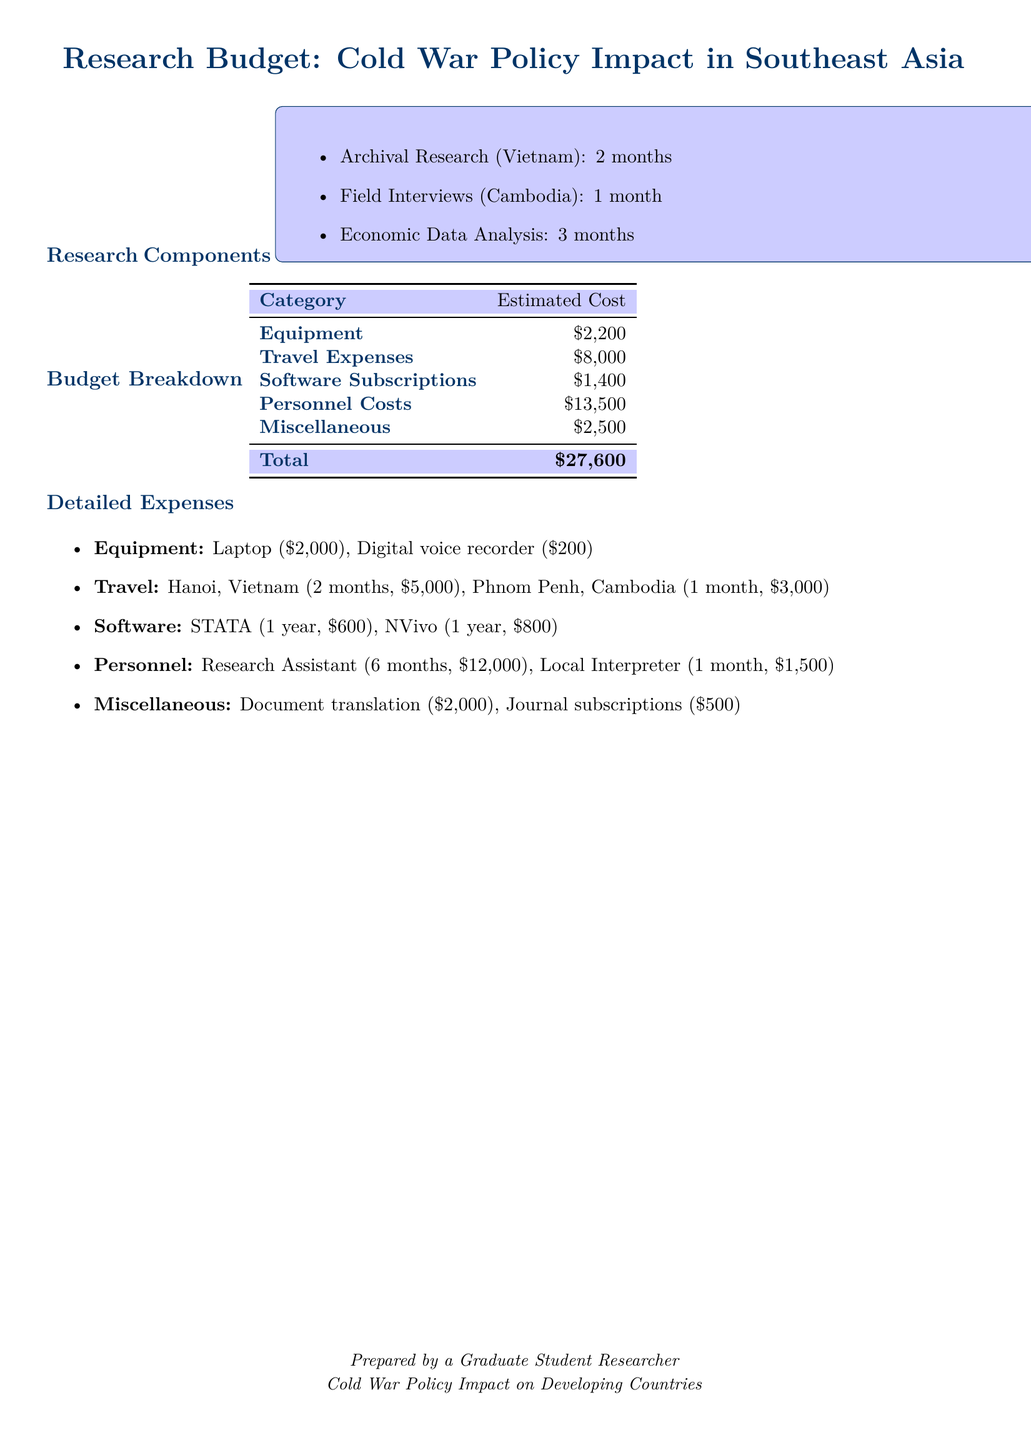What is the total estimated cost of the research? The total estimated cost is summarized in the budget breakdown section, which is $27,600.
Answer: $27,600 How many months will the archival research in Vietnam take? The duration of the archival research in Vietnam is specified as 2 months.
Answer: 2 months What is the cost of travel to Phnom Penh, Cambodia? The travel expense for Phnom Penh, Cambodia is listed as $3,000.
Answer: $3,000 Who will be hired as a research assistant? The personnel expenses indicate hiring a Research Assistant for 6 months.
Answer: Research Assistant What is the cost allocated for software subscriptions? The budget breakdown lists software subscriptions costing $1,400.
Answer: $1,400 How much is being spent on document translation? The detailed expenses include $2,000 for document translation.
Answer: $2,000 What type of software will be used for analysis? The types of software mentioned include STATA and NVivo.
Answer: STATA and NVivo How long will the field interviews in Cambodia last? The field interviews in Cambodia are mentioned to last for 1 month.
Answer: 1 month What is the estimated cost for miscellaneous expenses? The miscellaneous expenses are budgeted at $2,500 in total.
Answer: $2,500 